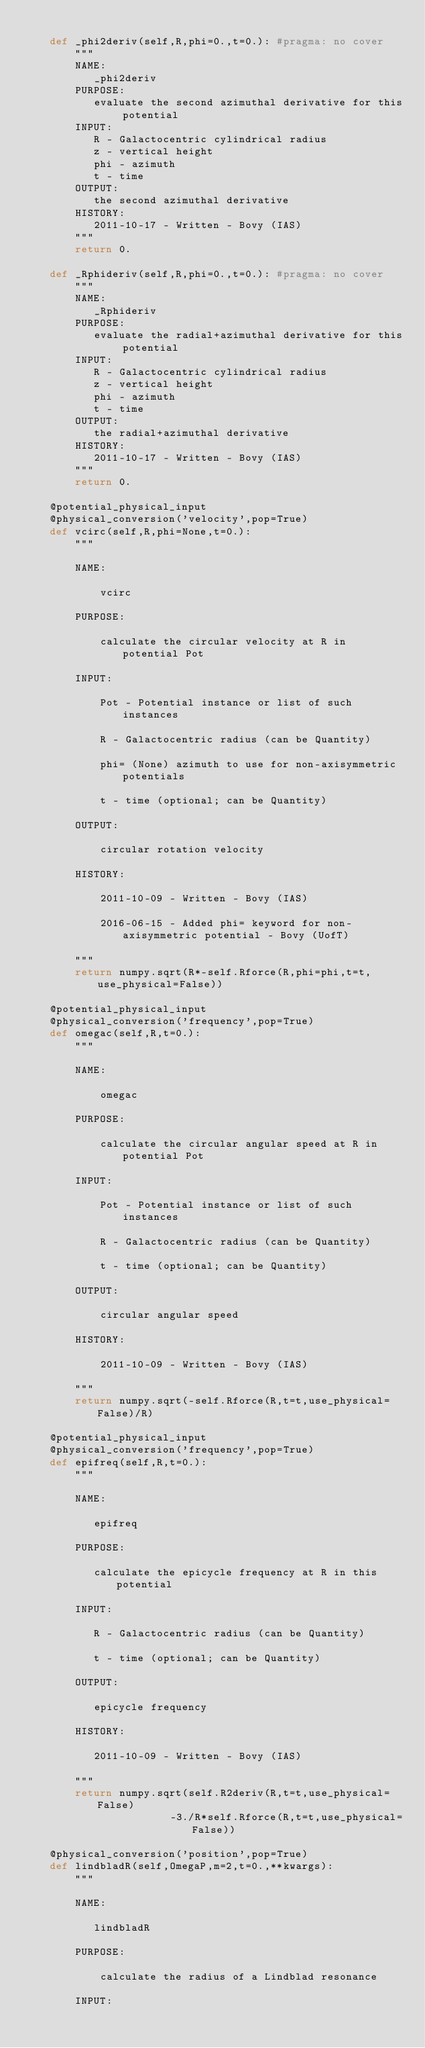Convert code to text. <code><loc_0><loc_0><loc_500><loc_500><_Python_>
    def _phi2deriv(self,R,phi=0.,t=0.): #pragma: no cover
        """
        NAME:
           _phi2deriv
        PURPOSE:
           evaluate the second azimuthal derivative for this potential
        INPUT:
           R - Galactocentric cylindrical radius
           z - vertical height
           phi - azimuth
           t - time
        OUTPUT:
           the second azimuthal derivative
        HISTORY:
           2011-10-17 - Written - Bovy (IAS)
        """
        return 0.

    def _Rphideriv(self,R,phi=0.,t=0.): #pragma: no cover
        """
        NAME:
           _Rphideriv
        PURPOSE:
           evaluate the radial+azimuthal derivative for this potential
        INPUT:
           R - Galactocentric cylindrical radius
           z - vertical height
           phi - azimuth
           t - time
        OUTPUT:
           the radial+azimuthal derivative
        HISTORY:
           2011-10-17 - Written - Bovy (IAS)
        """
        return 0.

    @potential_physical_input
    @physical_conversion('velocity',pop=True)
    def vcirc(self,R,phi=None,t=0.):
        """
        
        NAME:
        
            vcirc
        
        PURPOSE:
        
            calculate the circular velocity at R in potential Pot

        INPUT:
        
            Pot - Potential instance or list of such instances
        
            R - Galactocentric radius (can be Quantity)
        
            phi= (None) azimuth to use for non-axisymmetric potentials

            t - time (optional; can be Quantity)

        OUTPUT:
        
            circular rotation velocity
        
        HISTORY:
        
            2011-10-09 - Written - Bovy (IAS)
        
            2016-06-15 - Added phi= keyword for non-axisymmetric potential - Bovy (UofT)

        """
        return numpy.sqrt(R*-self.Rforce(R,phi=phi,t=t,use_physical=False))

    @potential_physical_input
    @physical_conversion('frequency',pop=True)
    def omegac(self,R,t=0.):
        """
        
        NAME:
        
            omegac
        
        PURPOSE:
        
            calculate the circular angular speed at R in potential Pot

        INPUT:
        
            Pot - Potential instance or list of such instances
        
            R - Galactocentric radius (can be Quantity)

            t - time (optional; can be Quantity)
        
        OUTPUT:
        
            circular angular speed
        
        HISTORY:
        
            2011-10-09 - Written - Bovy (IAS)
        
        """
        return numpy.sqrt(-self.Rforce(R,t=t,use_physical=False)/R)       

    @potential_physical_input
    @physical_conversion('frequency',pop=True)
    def epifreq(self,R,t=0.):
        """
        
        NAME:
        
           epifreq
        
        PURPOSE:
        
           calculate the epicycle frequency at R in this potential
        
        INPUT:
        
           R - Galactocentric radius (can be Quantity)

           t - time (optional; can be Quantity)
        
        OUTPUT:
        
           epicycle frequency
        
        HISTORY:
        
           2011-10-09 - Written - Bovy (IAS)
        
        """
        return numpy.sqrt(self.R2deriv(R,t=t,use_physical=False)
                       -3./R*self.Rforce(R,t=t,use_physical=False))

    @physical_conversion('position',pop=True)
    def lindbladR(self,OmegaP,m=2,t=0.,**kwargs):
        """
        
        NAME:
        
           lindbladR
        
        PURPOSE:
        
            calculate the radius of a Lindblad resonance
        
        INPUT:
        </code> 